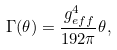<formula> <loc_0><loc_0><loc_500><loc_500>\Gamma ( \theta ) = \frac { g ^ { 4 } _ { e f f } } { 1 9 2 \pi } \theta ,</formula> 